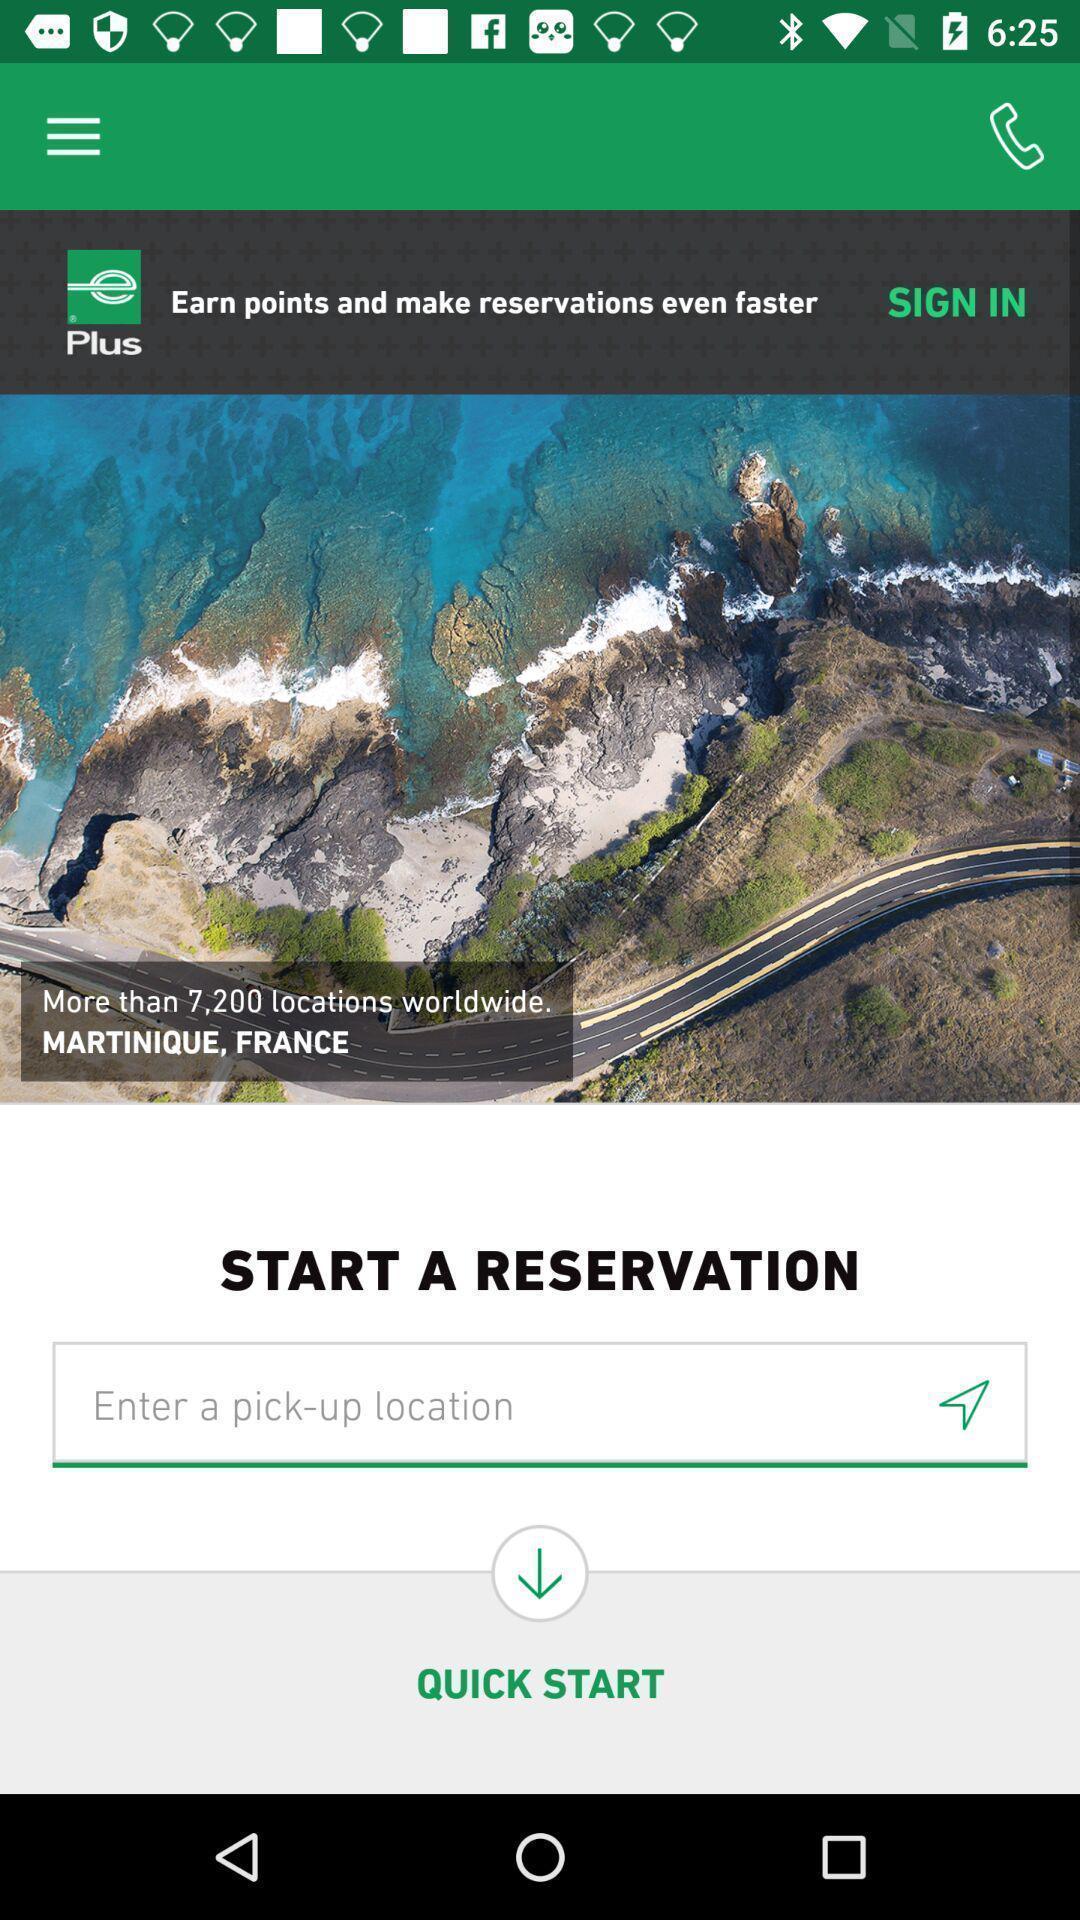Give me a summary of this screen capture. Starting page for the location guide app. 